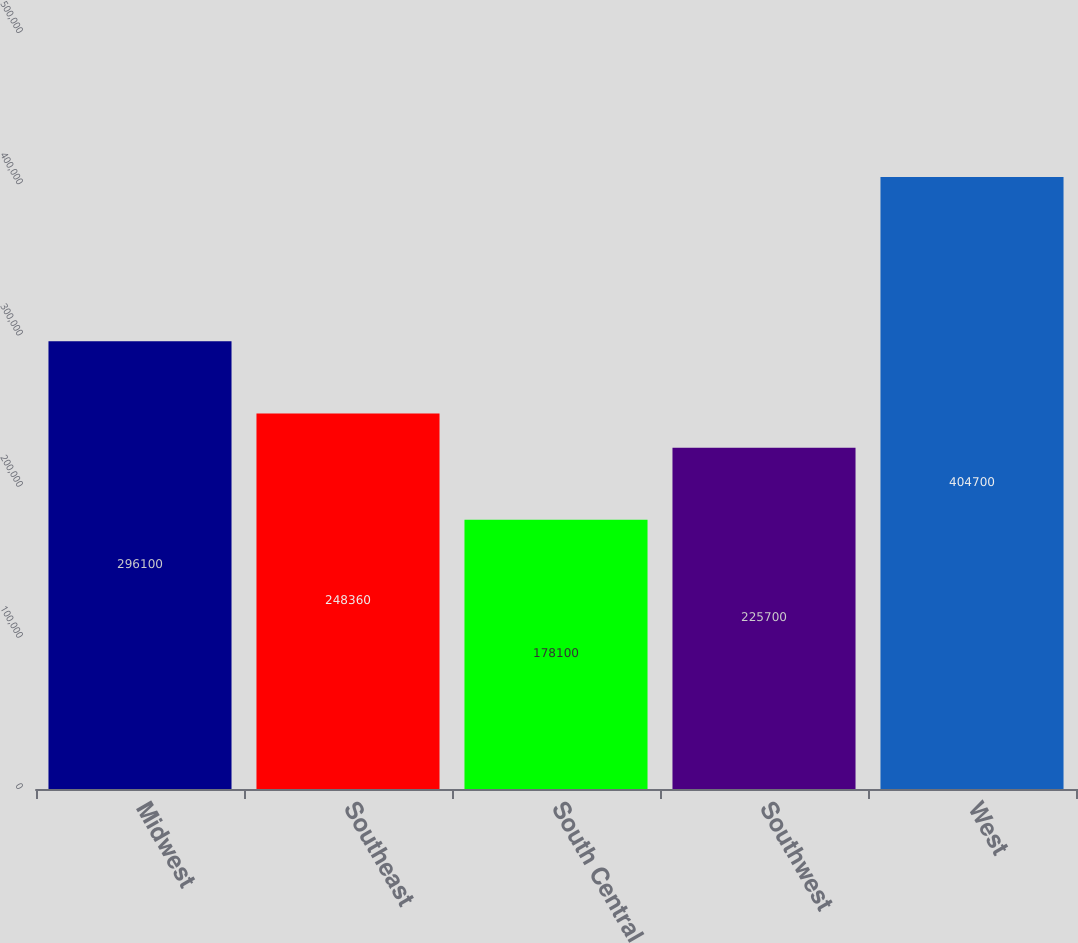Convert chart to OTSL. <chart><loc_0><loc_0><loc_500><loc_500><bar_chart><fcel>Midwest<fcel>Southeast<fcel>South Central<fcel>Southwest<fcel>West<nl><fcel>296100<fcel>248360<fcel>178100<fcel>225700<fcel>404700<nl></chart> 